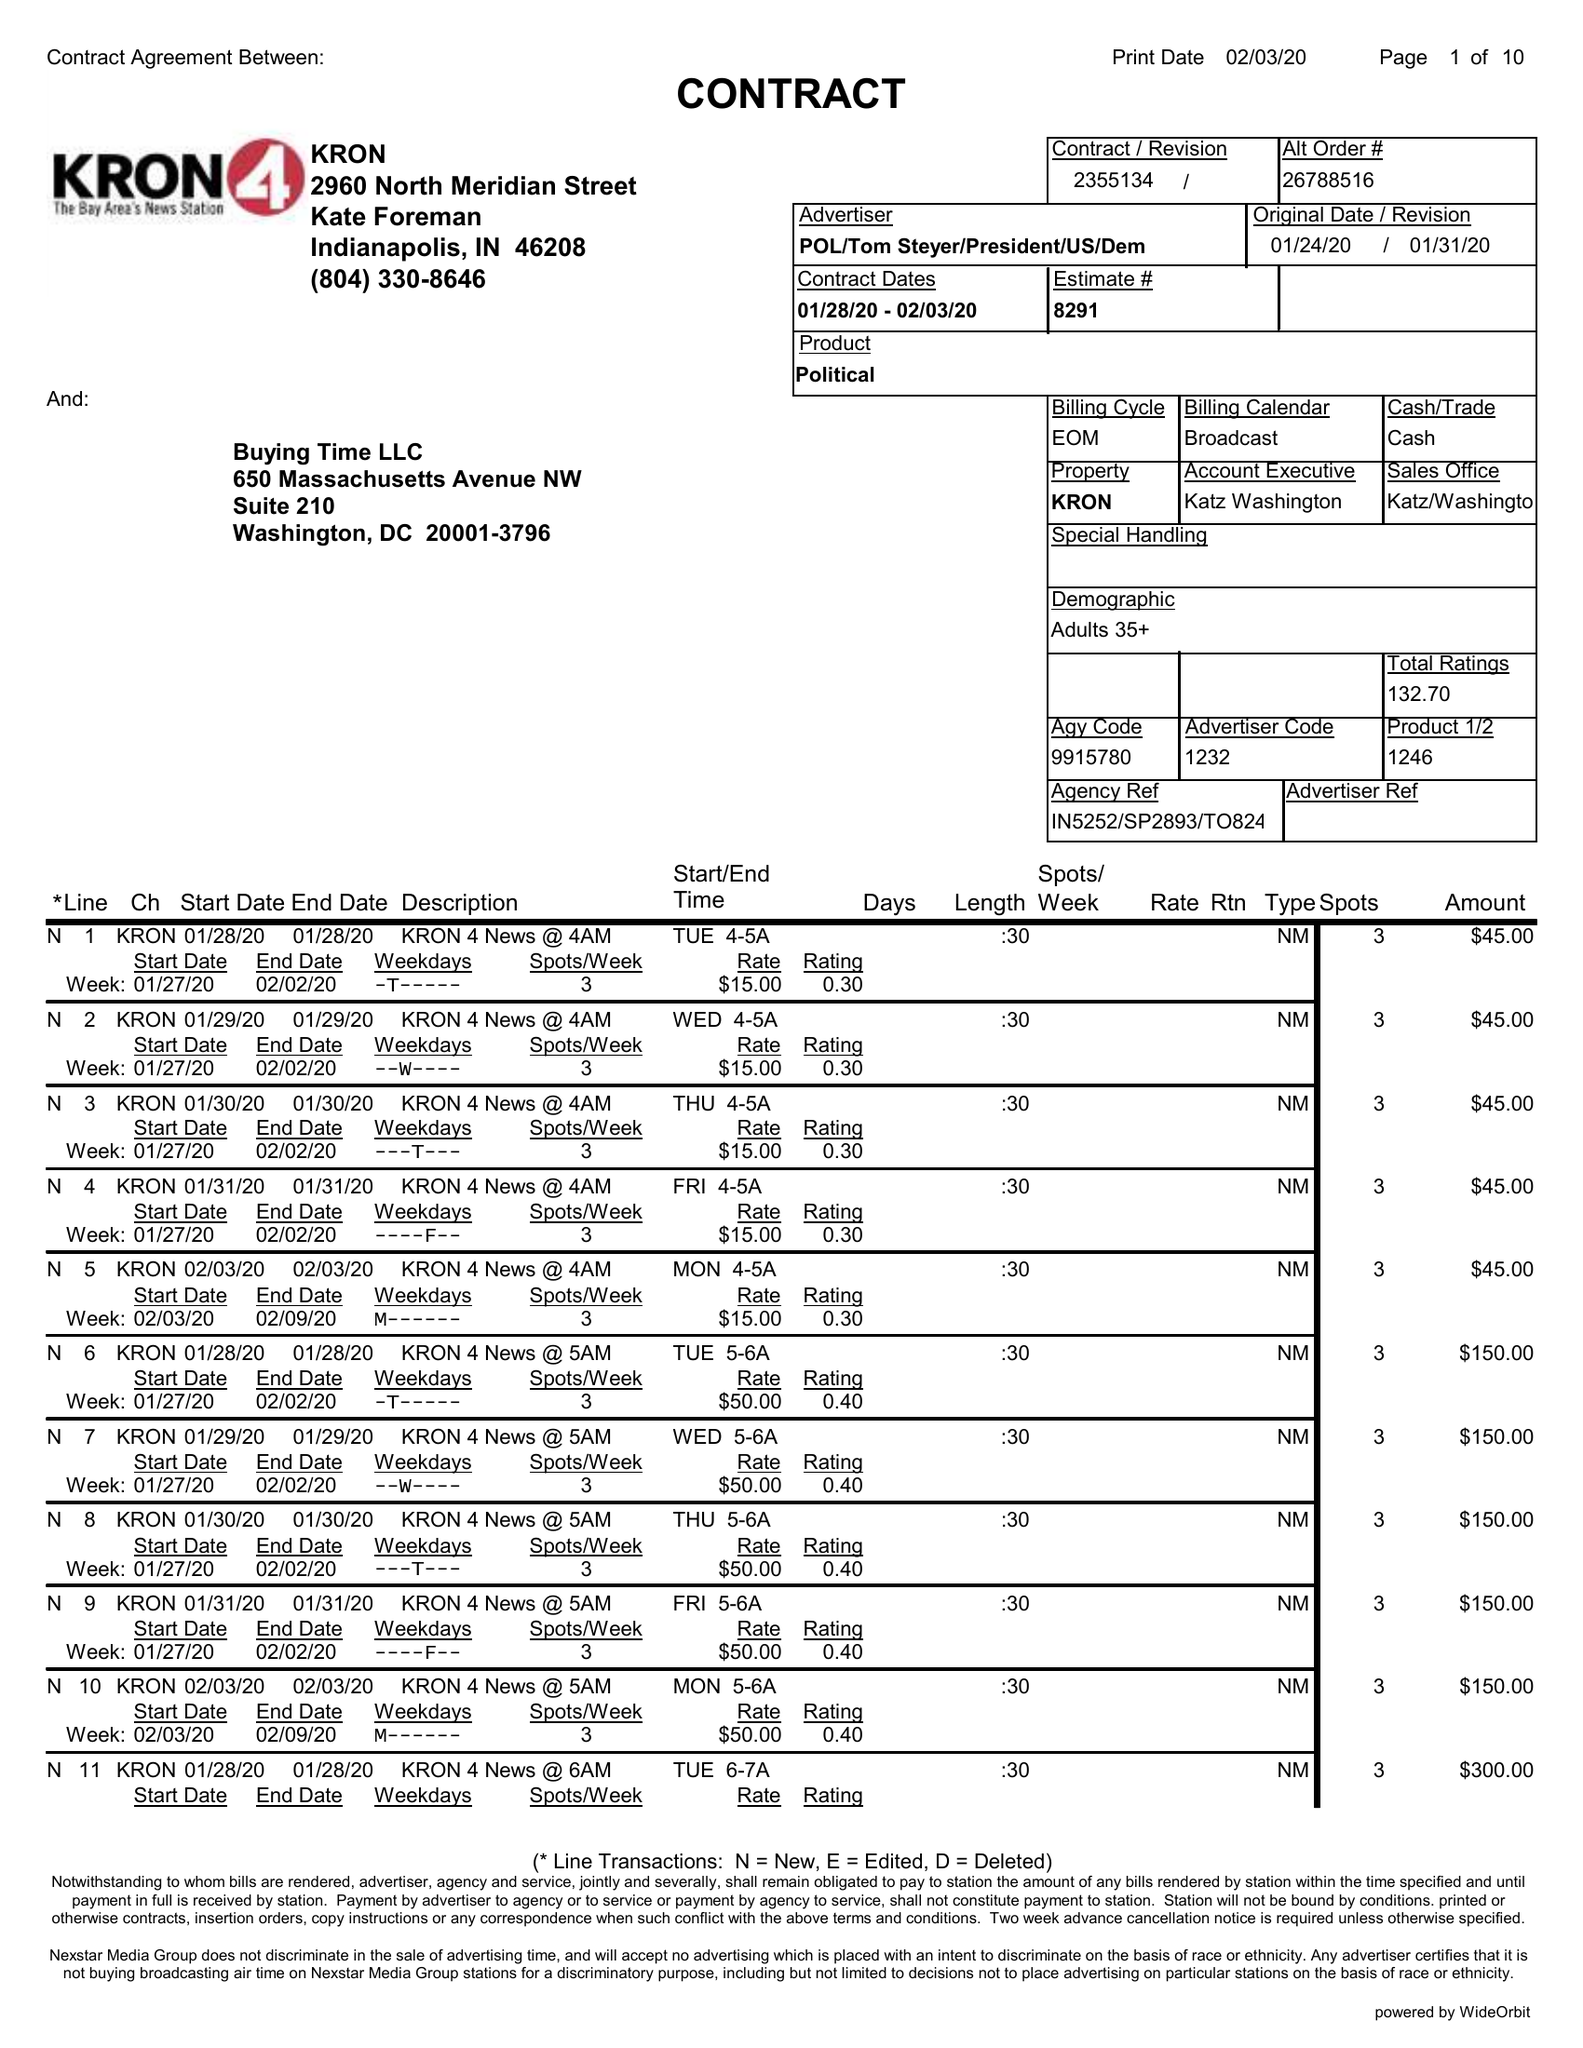What is the value for the gross_amount?
Answer the question using a single word or phrase. 29210.00 